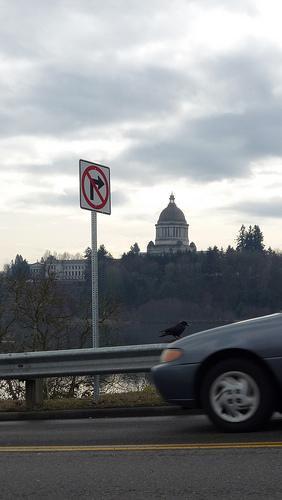How many signs are there?
Give a very brief answer. 1. 